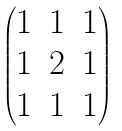<formula> <loc_0><loc_0><loc_500><loc_500>\begin{pmatrix} 1 & 1 & 1 \\ 1 & 2 & 1 \\ 1 & 1 & 1 \end{pmatrix}</formula> 